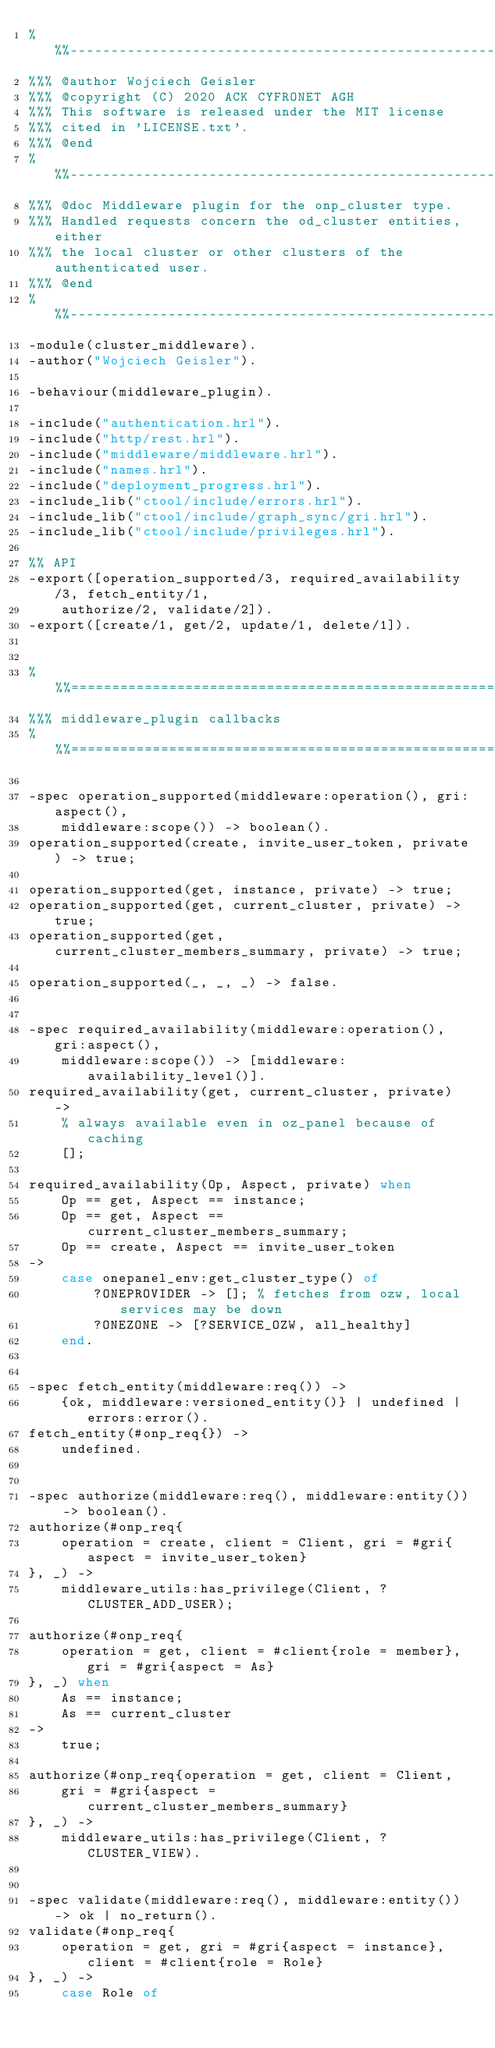<code> <loc_0><loc_0><loc_500><loc_500><_Erlang_>%%%-------------------------------------------------------------------
%%% @author Wojciech Geisler
%%% @copyright (C) 2020 ACK CYFRONET AGH
%%% This software is released under the MIT license
%%% cited in 'LICENSE.txt'.
%%% @end
%%%-------------------------------------------------------------------
%%% @doc Middleware plugin for the onp_cluster type.
%%% Handled requests concern the od_cluster entities, either
%%% the local cluster or other clusters of the authenticated user.
%%% @end
%%%-------------------------------------------------------------------
-module(cluster_middleware).
-author("Wojciech Geisler").

-behaviour(middleware_plugin).

-include("authentication.hrl").
-include("http/rest.hrl").
-include("middleware/middleware.hrl").
-include("names.hrl").
-include("deployment_progress.hrl").
-include_lib("ctool/include/errors.hrl").
-include_lib("ctool/include/graph_sync/gri.hrl").
-include_lib("ctool/include/privileges.hrl").

%% API
-export([operation_supported/3, required_availability/3, fetch_entity/1,
    authorize/2, validate/2]).
-export([create/1, get/2, update/1, delete/1]).


%%%===================================================================
%%% middleware_plugin callbacks
%%%===================================================================

-spec operation_supported(middleware:operation(), gri:aspect(),
    middleware:scope()) -> boolean().
operation_supported(create, invite_user_token, private) -> true;

operation_supported(get, instance, private) -> true;
operation_supported(get, current_cluster, private) -> true;
operation_supported(get, current_cluster_members_summary, private) -> true;

operation_supported(_, _, _) -> false.


-spec required_availability(middleware:operation(), gri:aspect(),
    middleware:scope()) -> [middleware:availability_level()].
required_availability(get, current_cluster, private) ->
    % always available even in oz_panel because of caching
    [];

required_availability(Op, Aspect, private) when
    Op == get, Aspect == instance;
    Op == get, Aspect == current_cluster_members_summary;
    Op == create, Aspect == invite_user_token
->
    case onepanel_env:get_cluster_type() of
        ?ONEPROVIDER -> []; % fetches from ozw, local services may be down
        ?ONEZONE -> [?SERVICE_OZW, all_healthy]
    end.


-spec fetch_entity(middleware:req()) ->
    {ok, middleware:versioned_entity()} | undefined | errors:error().
fetch_entity(#onp_req{}) ->
    undefined.


-spec authorize(middleware:req(), middleware:entity()) -> boolean().
authorize(#onp_req{
    operation = create, client = Client, gri = #gri{aspect = invite_user_token}
}, _) ->
    middleware_utils:has_privilege(Client, ?CLUSTER_ADD_USER);

authorize(#onp_req{
    operation = get, client = #client{role = member}, gri = #gri{aspect = As}
}, _) when
    As == instance;
    As == current_cluster
->
    true;

authorize(#onp_req{operation = get, client = Client,
    gri = #gri{aspect = current_cluster_members_summary}
}, _) ->
    middleware_utils:has_privilege(Client, ?CLUSTER_VIEW).


-spec validate(middleware:req(), middleware:entity()) -> ok | no_return().
validate(#onp_req{
    operation = get, gri = #gri{aspect = instance}, client = #client{role = Role}
}, _) ->
    case Role of</code> 